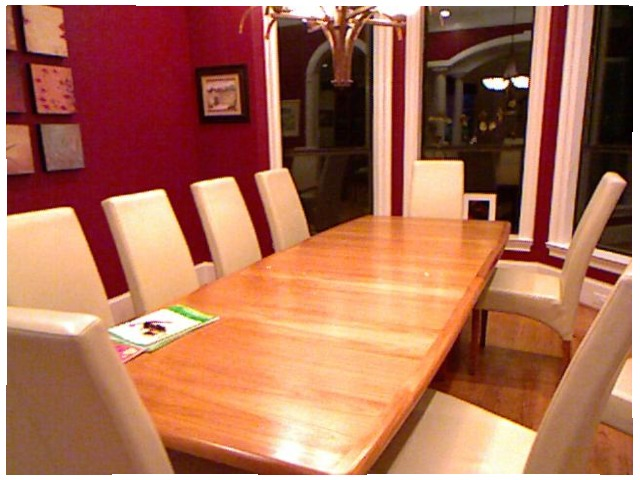<image>
Is the chair under the table? Yes. The chair is positioned underneath the table, with the table above it in the vertical space. Is the table under the book? Yes. The table is positioned underneath the book, with the book above it in the vertical space. Is the chair on the table? No. The chair is not positioned on the table. They may be near each other, but the chair is not supported by or resting on top of the table. Where is the picture in relation to the table? Is it on the table? No. The picture is not positioned on the table. They may be near each other, but the picture is not supported by or resting on top of the table. 